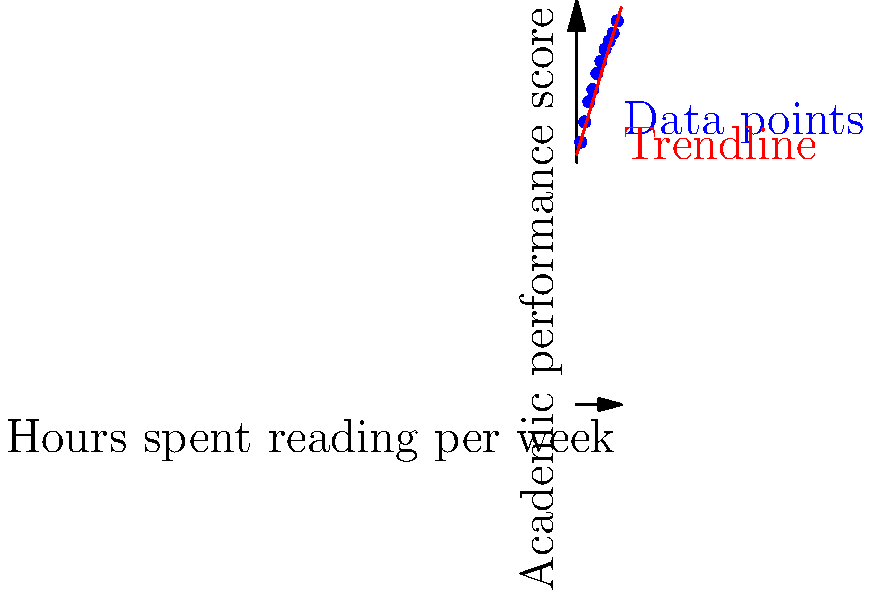Analyze the scatter plot showing the relationship between hours spent reading per week and academic performance scores. What conclusion can be drawn about the impact of reading habits on academic performance, and how might this information be used to encourage a love for learning through literature? To analyze the scatter plot and draw conclusions:

1. Observe the overall trend: The data points show a clear positive correlation between hours spent reading and academic performance scores.

2. Identify the trendline: The red line represents the best-fit linear relationship between the variables.

3. Interpret the correlation: As reading time increases, academic performance scores tend to improve.

4. Quantify the relationship: For each additional hour of reading per week, there's approximately a 3-3.5 point increase in academic performance score.

5. Consider the range: Scores improve from around 65 for 1 hour of reading to about 95 for 10 hours of reading per week.

6. Evaluate consistency: Most data points fall close to the trendline, indicating a strong and consistent relationship.

7. Apply to encouraging learning:
   a) Use this data to demonstrate the tangible benefits of reading to children.
   b) Emphasize that even small increases in reading time can lead to noticeable improvements in academic performance.
   c) Suggest incorporating diverse literature to make reading more engaging and foster a well-rounded education.
   d) Encourage parents to create a reading-friendly environment at home to support academic growth.

8. Consider limitations: While there's a strong correlation, other factors may also influence academic performance.
Answer: Strong positive correlation between reading time and academic performance; can be used to promote reading as a key to academic success and foster a love for learning through literature. 